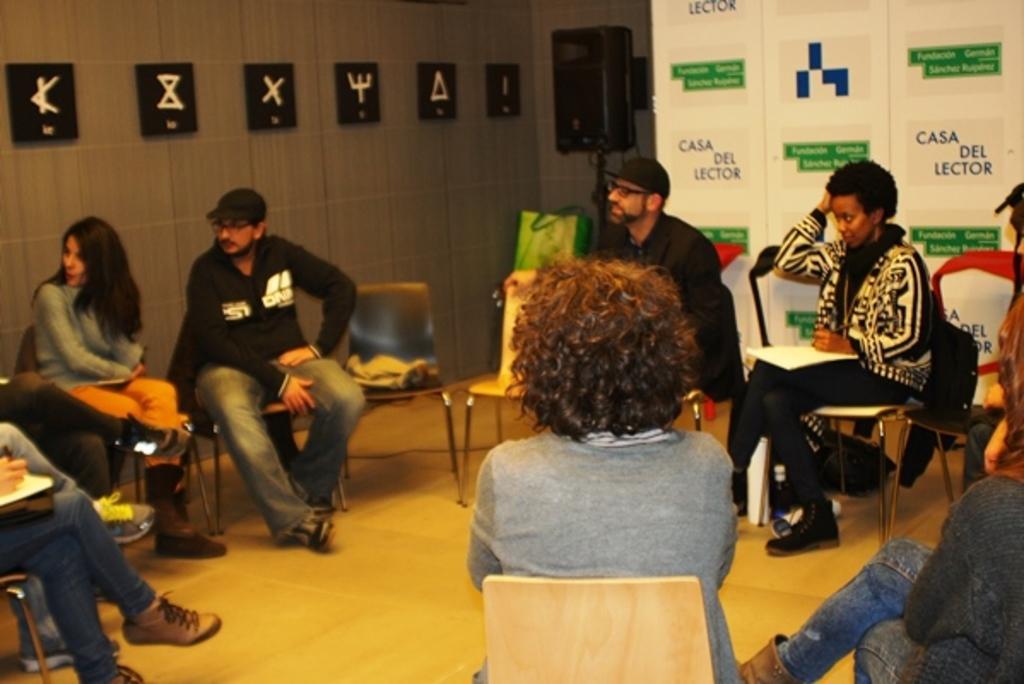Can you describe this image briefly? In this image there are persons sitting. In the background there are banners with some text written on it and there are frames on the wall. 